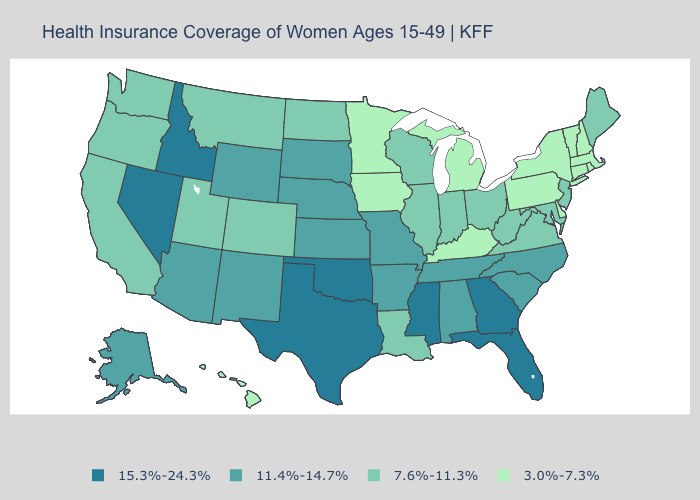Does the first symbol in the legend represent the smallest category?
Concise answer only. No. What is the lowest value in the West?
Quick response, please. 3.0%-7.3%. Which states hav the highest value in the South?
Write a very short answer. Florida, Georgia, Mississippi, Oklahoma, Texas. What is the lowest value in the USA?
Be succinct. 3.0%-7.3%. Does New Hampshire have the lowest value in the USA?
Give a very brief answer. Yes. Which states hav the highest value in the MidWest?
Keep it brief. Kansas, Missouri, Nebraska, South Dakota. Which states have the lowest value in the South?
Concise answer only. Delaware, Kentucky. Does Kentucky have the lowest value in the South?
Be succinct. Yes. What is the highest value in the USA?
Concise answer only. 15.3%-24.3%. Does Alabama have a higher value than Colorado?
Keep it brief. Yes. Name the states that have a value in the range 11.4%-14.7%?
Write a very short answer. Alabama, Alaska, Arizona, Arkansas, Kansas, Missouri, Nebraska, New Mexico, North Carolina, South Carolina, South Dakota, Tennessee, Wyoming. What is the value of Nevada?
Concise answer only. 15.3%-24.3%. What is the highest value in states that border Arizona?
Quick response, please. 15.3%-24.3%. Name the states that have a value in the range 3.0%-7.3%?
Give a very brief answer. Connecticut, Delaware, Hawaii, Iowa, Kentucky, Massachusetts, Michigan, Minnesota, New Hampshire, New York, Pennsylvania, Rhode Island, Vermont. What is the lowest value in states that border West Virginia?
Short answer required. 3.0%-7.3%. 